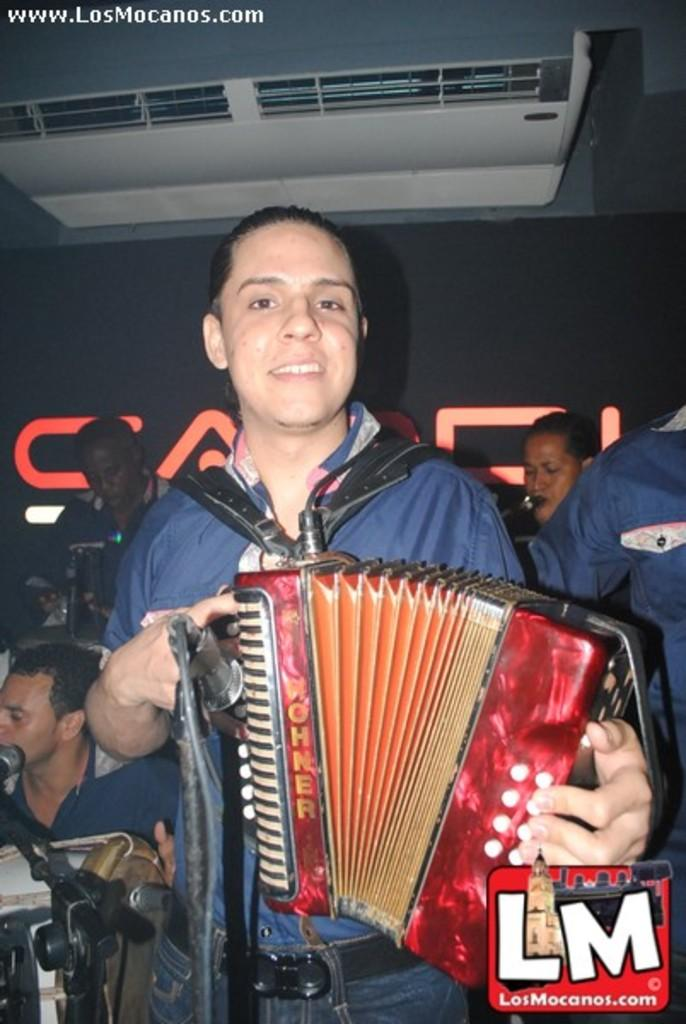What is the person in the image doing? The person is standing and playing a red harmonium. What can be seen at the front of the image? There is a microphone at the front. Are there any other people in the image? Yes, there are other people behind the person playing the harmonium. What is the color of the background in the image? The background of the image is black. What is present on the top of the image? An air conditioning unit (AC) is present on the top of the image. Can you see any blood on the harmonium in the image? No, there is no blood visible on the harmonium or anywhere else in the image. Is there a horse present in the image? No, there is no horse present in the image. 